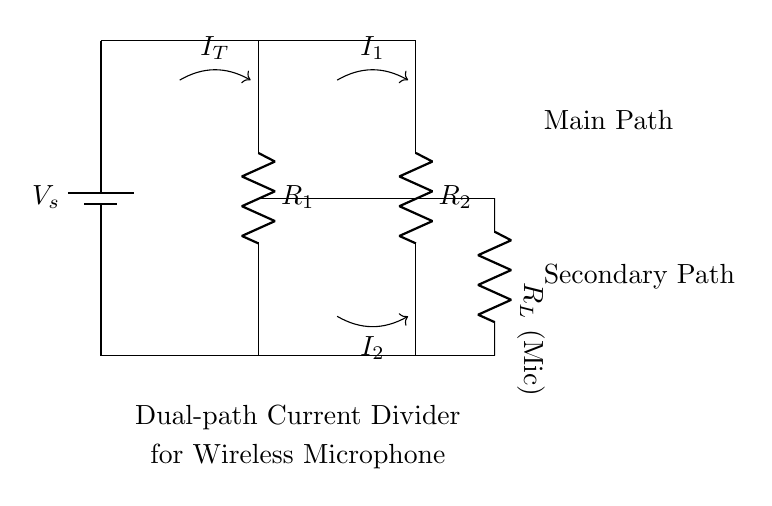What is the supply voltage in the circuit? The supply voltage, labeled as V_s in the circuit diagram, represents the potential difference provided by the battery. Since it is not specified in the diagram, we would typically assume it to be any standard battery voltage commonly used, such as 9V.
Answer: V_s What are the values of the resistors in this circuit? The circuit shows two resistors, R_1 and R_2, but their specific values are not provided in the diagram. They could be standard resistor values used in audio equipment but need to be labeled for clarification.
Answer: R_1, R_2 What is the role of R_L in this circuit? R_L is connected as a load to the microphone, representing the resistance that the microphone presents to the circuit. It is essential for considering the total current division that occurs in the paths.
Answer: Load How does current divide in this circuit? The total current I_T splits into I_1 and I_2 at the junction where R_1 and R_2 connect. The ratio of the currents is inversely related to the resistance values. Therefore, the formula I_1/I_2 = R_2/R_1 can be used to calculate individual currents. This reflects how a current divider functions based on resistance.
Answer: Ratio of resistances What happens if R_1 decreases while R_2 remains constant? If R_1 decreases, the current through R_1 (I_1) will increase because, by Ohm's law and the principle of current division, the current will take the path of least resistance. As a result, I_2 will decrease to maintain the total current (I_T) constant. This showcases how the current divider operates under changing resistances.
Answer: I_1 increases, I_2 decreases What is the purpose of having two paths in the current divider? The purpose of having two paths is to manage battery drain effectively by directing current to R_L (the microphone) based on load demands. It allows for efficient use of power, where adjusting the current flow to different paths can extend battery life in wireless microphone systems, particularly during variable usage scenarios.
Answer: Manage battery drain 